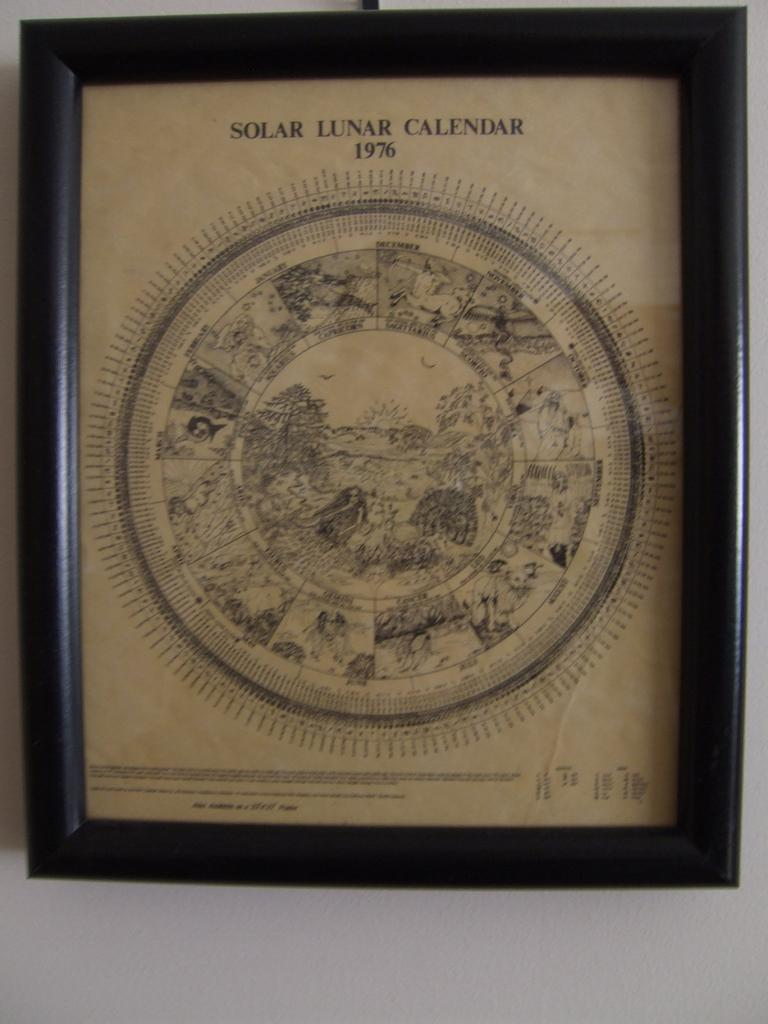<image>
Relay a brief, clear account of the picture shown. A solar lunar calendar from 1976 drawn in pen and ink. 